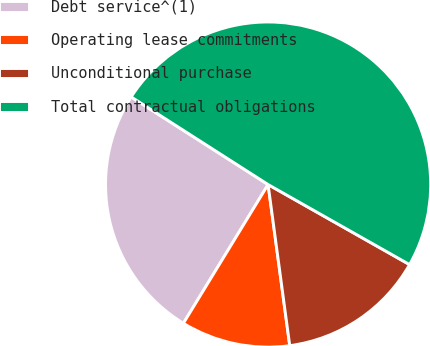<chart> <loc_0><loc_0><loc_500><loc_500><pie_chart><fcel>Debt service^(1)<fcel>Operating lease commitments<fcel>Unconditional purchase<fcel>Total contractual obligations<nl><fcel>25.34%<fcel>10.85%<fcel>14.68%<fcel>49.14%<nl></chart> 